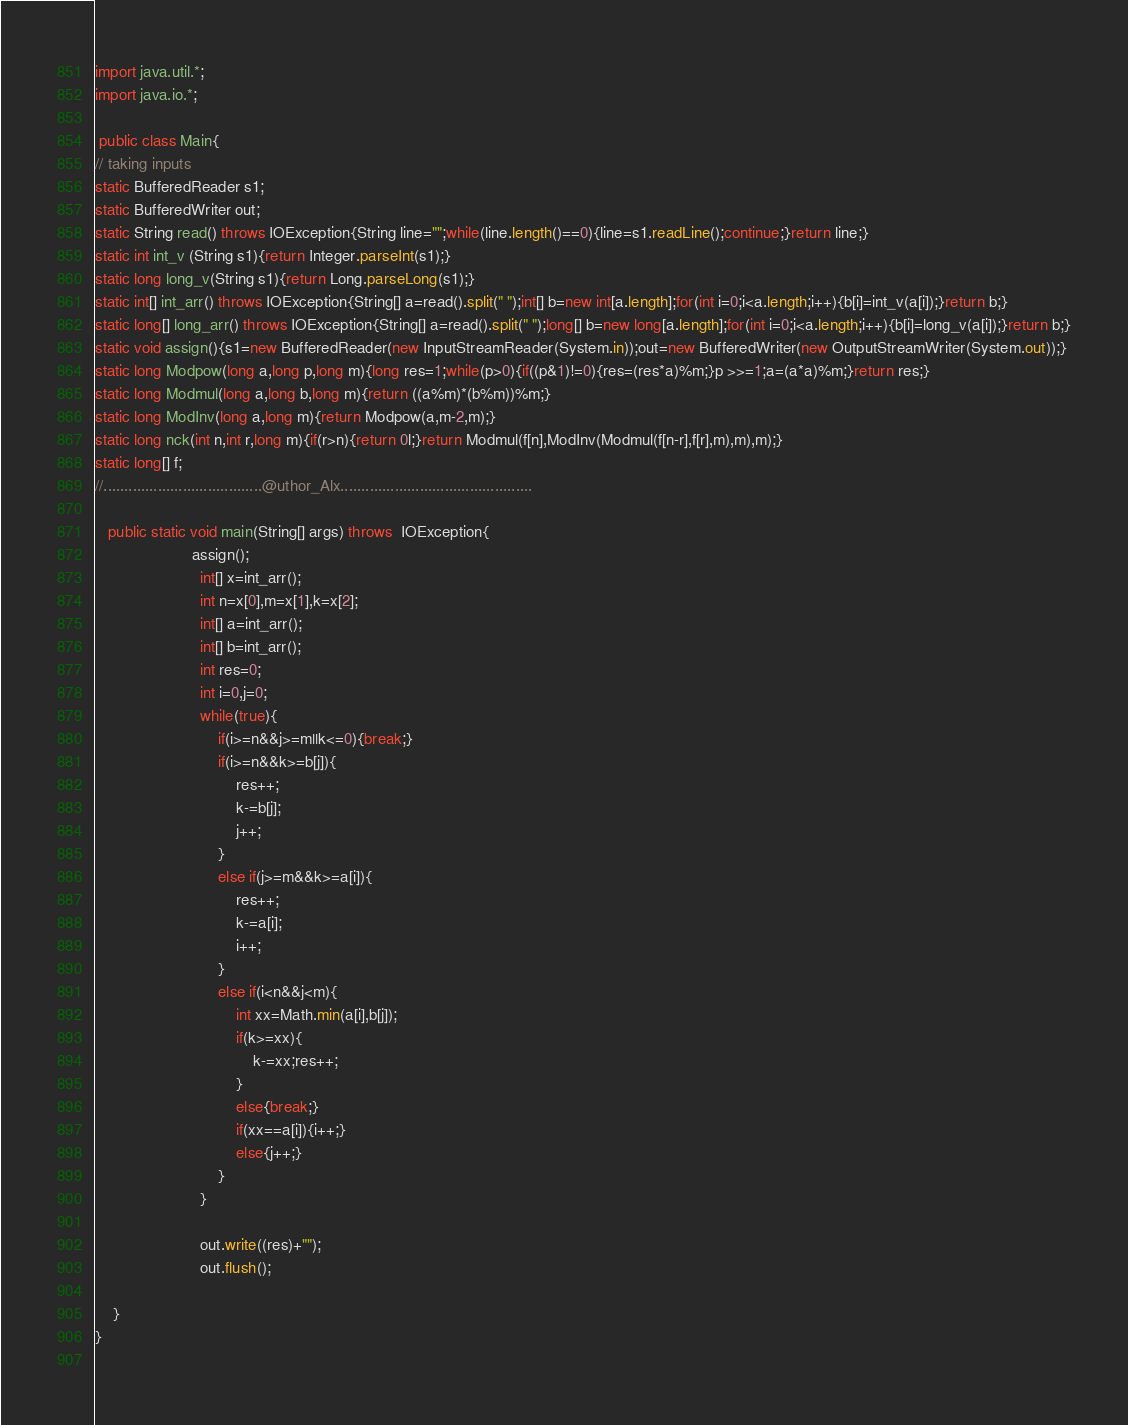<code> <loc_0><loc_0><loc_500><loc_500><_Java_>import java.util.*;
import java.io.*;

 public class Main{
// taking inputs
static BufferedReader s1;
static BufferedWriter out;
static String read() throws IOException{String line="";while(line.length()==0){line=s1.readLine();continue;}return line;}
static int int_v (String s1){return Integer.parseInt(s1);}
static long long_v(String s1){return Long.parseLong(s1);}
static int[] int_arr() throws IOException{String[] a=read().split(" ");int[] b=new int[a.length];for(int i=0;i<a.length;i++){b[i]=int_v(a[i]);}return b;}
static long[] long_arr() throws IOException{String[] a=read().split(" ");long[] b=new long[a.length];for(int i=0;i<a.length;i++){b[i]=long_v(a[i]);}return b;}
static void assign(){s1=new BufferedReader(new InputStreamReader(System.in));out=new BufferedWriter(new OutputStreamWriter(System.out));}
static long Modpow(long a,long p,long m){long res=1;while(p>0){if((p&1)!=0){res=(res*a)%m;}p >>=1;a=(a*a)%m;}return res;}
static long Modmul(long a,long b,long m){return ((a%m)*(b%m))%m;}
static long ModInv(long a,long m){return Modpow(a,m-2,m);}
static long nck(int n,int r,long m){if(r>n){return 0l;}return Modmul(f[n],ModInv(Modmul(f[n-r],f[r],m),m),m);}
static long[] f;
//......................................@uthor_Alx..............................................

   public static void main(String[] args) throws  IOException{
	        		  assign();
	        		  	int[] x=int_arr();
	        		  	int n=x[0],m=x[1],k=x[2];
	        		  	int[] a=int_arr();
	        		  	int[] b=int_arr();
	        		  	int res=0;
	        		  	int i=0,j=0;
	        		  	while(true){
	        		  		if(i>=n&&j>=m||k<=0){break;}
	        		  		if(i>=n&&k>=b[j]){
	        		  			res++;
	        		  			k-=b[j];
	        		  			j++;
	        		  		}
	        		  		else if(j>=m&&k>=a[i]){
	        		  			res++;
	        		  			k-=a[i];
	        		  			i++;
	        		  		}
	        		  		else if(i<n&&j<m){
	        		  			int xx=Math.min(a[i],b[j]);
	        		  			if(k>=xx){
	        		  				k-=xx;res++;
	        		  			}
	        		  			else{break;}
	        		  			if(xx==a[i]){i++;}
	        		  			else{j++;}
	        		  		}
	        		  	}
	        		  	
	        		  	out.write((res)+"");
                      	out.flush();
	        		 
	}
}
	       
</code> 